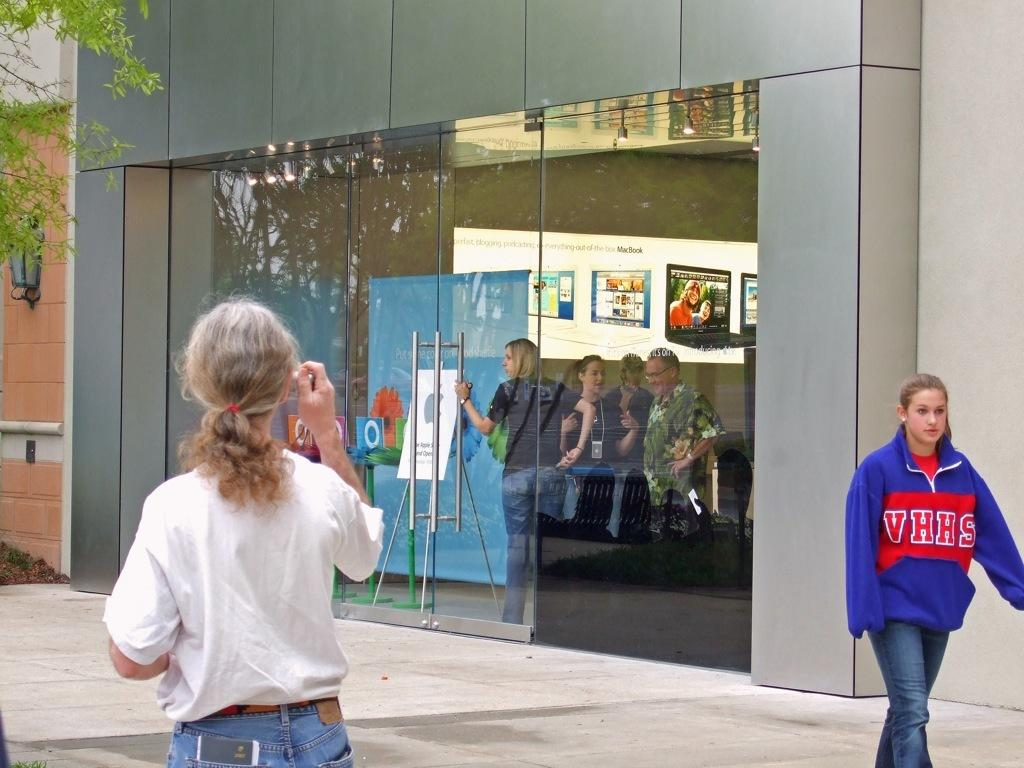<image>
Summarize the visual content of the image. A woman outside of building wearing a blue and red VHHS 